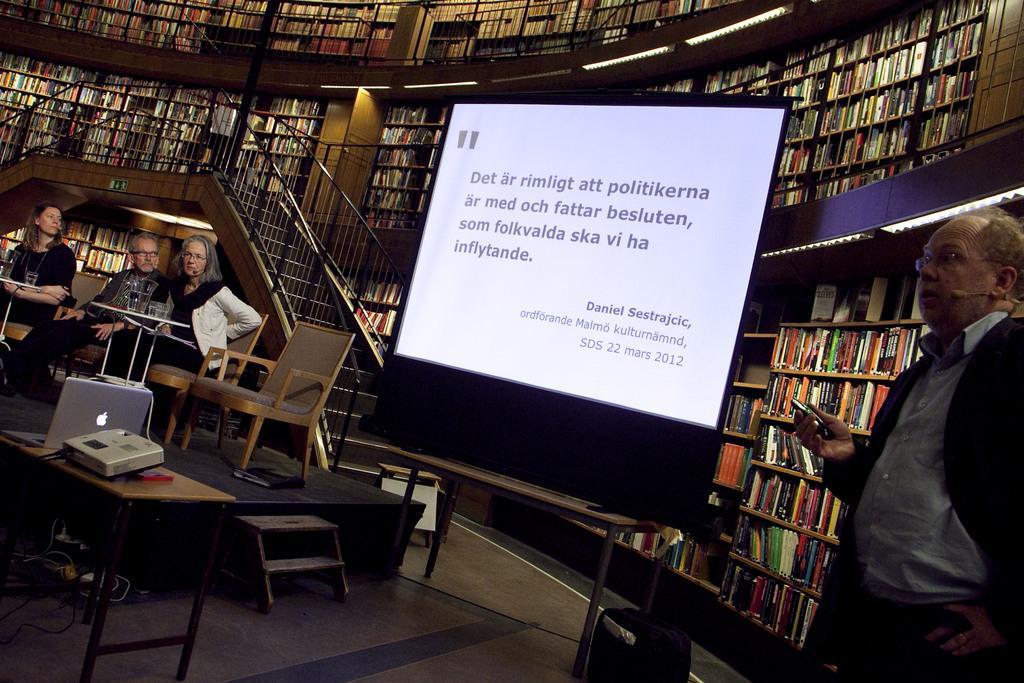Please provide a concise description of this image. Racks are filled with books. This is screen. This are steps That 3 persons are sitting on a chair. On table there is a glass. On this table there is a projector and laptop. This person is standing and worn mic. This is bag. 